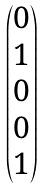Convert formula to latex. <formula><loc_0><loc_0><loc_500><loc_500>\begin{pmatrix} 0 \\ 1 \\ 0 \\ 0 \\ 1 \end{pmatrix}</formula> 